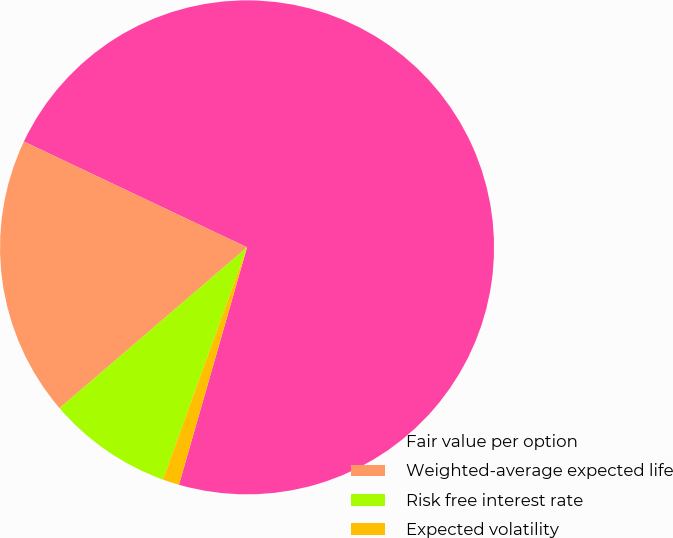Convert chart to OTSL. <chart><loc_0><loc_0><loc_500><loc_500><pie_chart><fcel>Fair value per option<fcel>Weighted-average expected life<fcel>Risk free interest rate<fcel>Expected volatility<nl><fcel>72.4%<fcel>18.33%<fcel>8.19%<fcel>1.08%<nl></chart> 